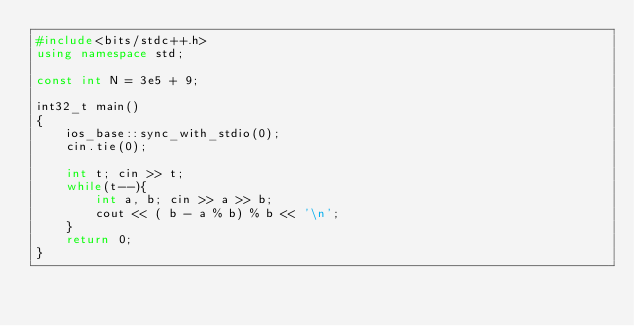<code> <loc_0><loc_0><loc_500><loc_500><_C++_>#include<bits/stdc++.h>
using namespace std;

const int N = 3e5 + 9;

int32_t main()
{
    ios_base::sync_with_stdio(0);
    cin.tie(0);

    int t; cin >> t;
    while(t--){
        int a, b; cin >> a >> b;
        cout << ( b - a % b) % b << '\n';
    }
    return 0;
}</code> 